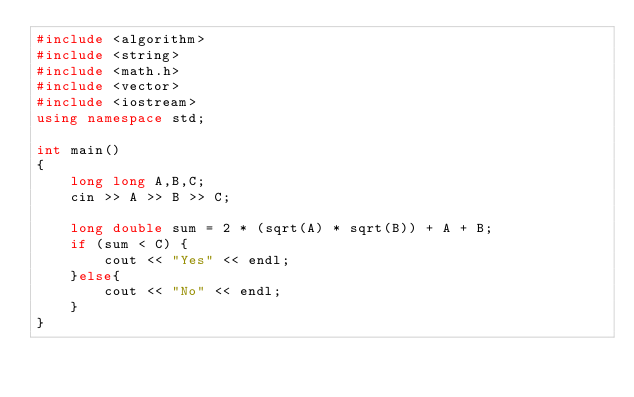Convert code to text. <code><loc_0><loc_0><loc_500><loc_500><_C++_>#include <algorithm>
#include <string>
#include <math.h>
#include <vector>
#include <iostream>
using namespace std;

int main()
{
    long long A,B,C;
    cin >> A >> B >> C;
    
    long double sum = 2 * (sqrt(A) * sqrt(B)) + A + B;
    if (sum < C) {
        cout << "Yes" << endl;
    }else{
        cout << "No" << endl;
    }
}</code> 